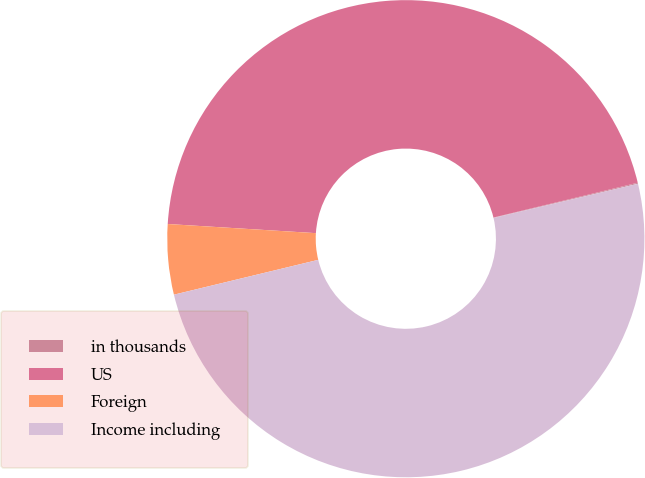Convert chart. <chart><loc_0><loc_0><loc_500><loc_500><pie_chart><fcel>in thousands<fcel>US<fcel>Foreign<fcel>Income including<nl><fcel>0.07%<fcel>45.25%<fcel>4.75%<fcel>49.93%<nl></chart> 